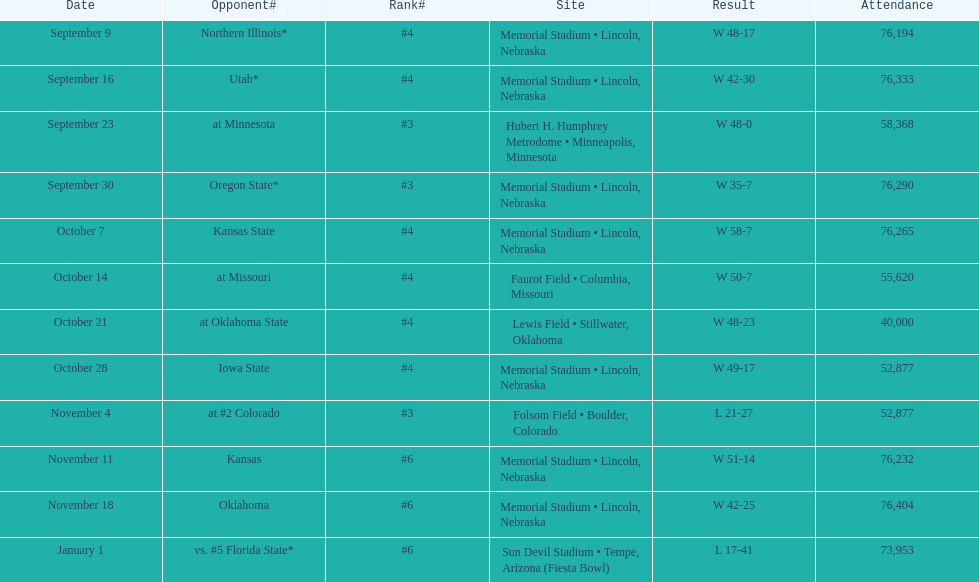Help me parse the entirety of this table. {'header': ['Date', 'Opponent#', 'Rank#', 'Site', 'Result', 'Attendance'], 'rows': [['September 9', 'Northern Illinois*', '#4', 'Memorial Stadium • Lincoln, Nebraska', 'W\xa048-17', '76,194'], ['September 16', 'Utah*', '#4', 'Memorial Stadium • Lincoln, Nebraska', 'W\xa042-30', '76,333'], ['September 23', 'at\xa0Minnesota', '#3', 'Hubert H. Humphrey Metrodome • Minneapolis, Minnesota', 'W\xa048-0', '58,368'], ['September 30', 'Oregon State*', '#3', 'Memorial Stadium • Lincoln, Nebraska', 'W\xa035-7', '76,290'], ['October 7', 'Kansas State', '#4', 'Memorial Stadium • Lincoln, Nebraska', 'W\xa058-7', '76,265'], ['October 14', 'at\xa0Missouri', '#4', 'Faurot Field • Columbia, Missouri', 'W\xa050-7', '55,620'], ['October 21', 'at\xa0Oklahoma State', '#4', 'Lewis Field • Stillwater, Oklahoma', 'W\xa048-23', '40,000'], ['October 28', 'Iowa State', '#4', 'Memorial Stadium • Lincoln, Nebraska', 'W\xa049-17', '52,877'], ['November 4', 'at\xa0#2\xa0Colorado', '#3', 'Folsom Field • Boulder, Colorado', 'L\xa021-27', '52,877'], ['November 11', 'Kansas', '#6', 'Memorial Stadium • Lincoln, Nebraska', 'W\xa051-14', '76,232'], ['November 18', 'Oklahoma', '#6', 'Memorial Stadium • Lincoln, Nebraska', 'W\xa042-25', '76,404'], ['January 1', 'vs.\xa0#5\xa0Florida State*', '#6', 'Sun Devil Stadium • Tempe, Arizona (Fiesta Bowl)', 'L\xa017-41', '73,953']]} What's the number of people who attended the oregon state game? 76,290. 